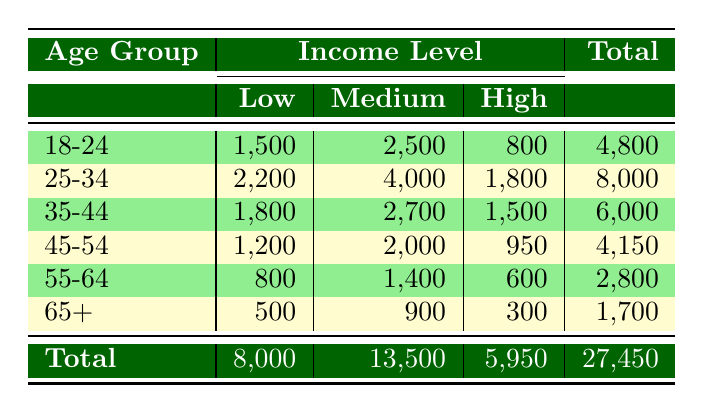What age group has the highest number of patients accessing medical cannabis? The age group "25-34" has the highest total of patients accessing medical cannabis at 8,000, which is the highest compared to other age groups listed in the total column.
Answer: 25-34 What is the total number of patients accessing medical cannabis in the "Low" income level? The sum of patients in the "Low" income level across all age groups is calculated as follows: 1,500 (18-24) + 2,200 (25-34) + 1,800 (35-44) + 1,200 (45-54) + 800 (55-64) + 500 (65+) = 8,000.
Answer: 8,000 Is there a significant drop in the number of patients accessing medical cannabis from the "Medium" income level in the age group "18-24" to the age group "65+"? Yes, the number of patients in the "Medium" income level decreases from 2,500 (18-24) to 900 (65+), which is a drop of 1,600 patients, indicating a significant decrease.
Answer: Yes What is the total number of patients accessing medical cannabis in the age group "55-64"? The total for the age group "55-64" can be found by adding patients from all income levels: 800 (Low) + 1,400 (Medium) + 600 (High) = 2,800.
Answer: 2,800 What is the ratio of patients accessing medical cannabis in the "High" income level for the age group "35-44" compared to the "65+" age group? The number of patients accessing in the "High" income level for "35-44" is 1,500 and for "65+" it is 300. The ratio is 1,500/300, which simplifies to 5:1.
Answer: 5:1 Which income level has the lowest total number of patients accessing cannabis across all age groups? By examining the totals, the "High" income level has a total of 5,950 patients compared to 8,000 in the "Low" and 13,500 in the "Medium" levels, making "High" the lowest.
Answer: High What age group demonstrates the most patients accessing medical cannabis in the "High" income category? The age group "25-34" has the highest number of patients accessing at 1,800 in the "High" income level, more than any other age group when looking at the corresponding values.
Answer: 25-34 What is the average number of patients accessing medical cannabis in the "Low" income level across all age groups? The total number of patients in the "Low" income level is 8,000 (calculated previously), and there are 6 age groups. Thus, the average is 8,000 / 6 = 1,333.33.
Answer: 1,333.33 